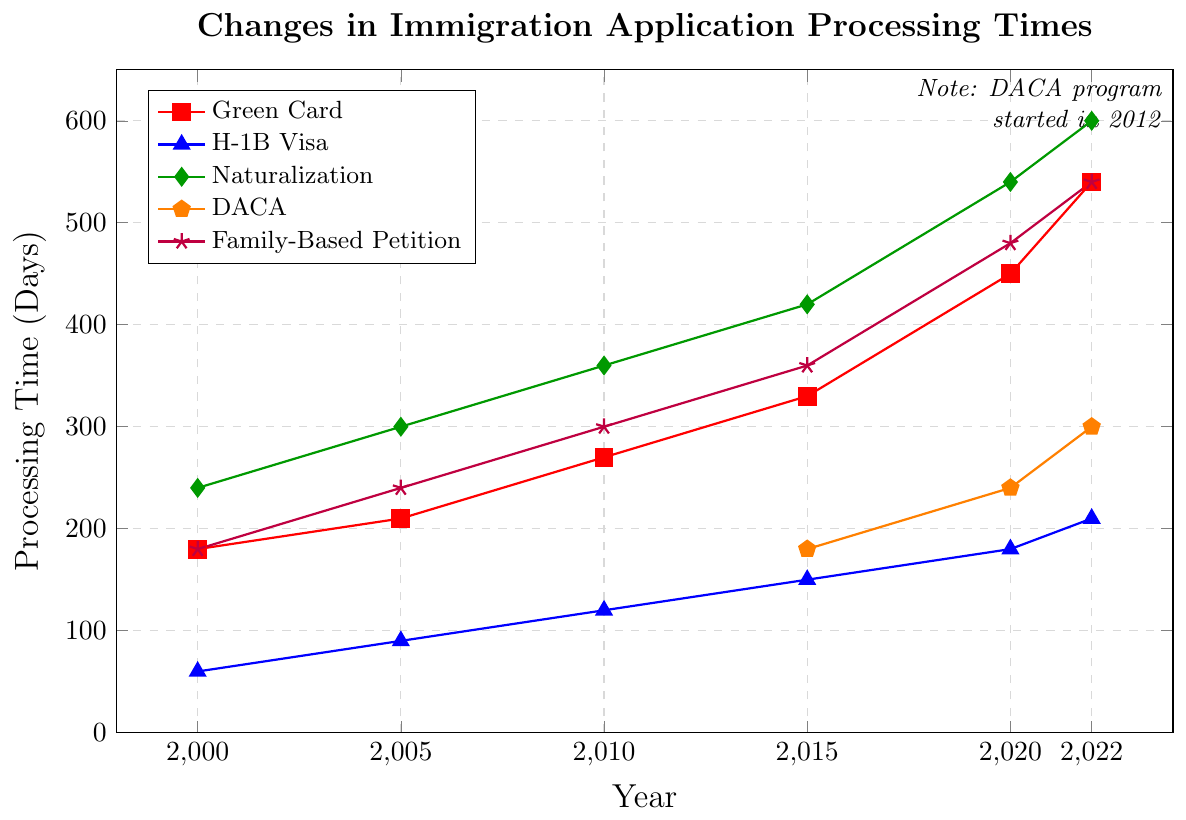what is the processing time for Naturalization in 2020? Locate the naturalization line (green) and find the point corresponding to the year 2020. The processing time indicated is 540 days.
Answer: 540 days Which immigration application had the shortest processing time in 2000? Compare the processing times for all applications in the year 2000. The H-1B Visa had the shortest processing time at 60 days.
Answer: H-1B Visa How much did the processing time for Green Cards increase from 2000 to 2022? Subtract the processing time in 2000 from that in 2022 for Green Cards: 540 days - 180 days = 360 days.
Answer: 360 days Compare the processing times for DACA and Family-Based Petitions in 2022. Which one is longer? Locate the processing times for both DACA (300 days) and Family-Based Petitions (540 days) in 2022. The Family-Based Petition processing time is longer.
Answer: Family-Based Petition What is the average processing time for H-1B Visa applications over the years provided? Sum the processing times for H-1B Visa across all available years and then divide by the number of years: (60 + 90 + 120 + 150 + 180 + 210) / 6 = 135 days.
Answer: 135 days Which year saw the largest increase in processing time for Naturalization compared to the previous year? Calculate the differences in naturalization processing times between consecutive years and find the largest: 2005-2000 = 60, 2010-2005 = 60, 2015-2010 = 60, 2020-2015 = 120, 2022-2020 = 60. The year 2020 saw the largest increase of 120 days.
Answer: 2020 What color represents the data for Family-Based Petition processing times? Identify the color associated with the Family-Based Petition line. It is purple.
Answer: purple By how many days did the processing time for H-1B Visa change from 2015 to 2020? Subtract the processing time in 2015 from that in 2020 for H-1B Visa: 180 days - 150 days = 30 days.
Answer: 30 days What was the initial processing time for the DACA program in 2015? Locate the DACA data point for 2015. The initial processing time was 180 days.
Answer: 180 days 